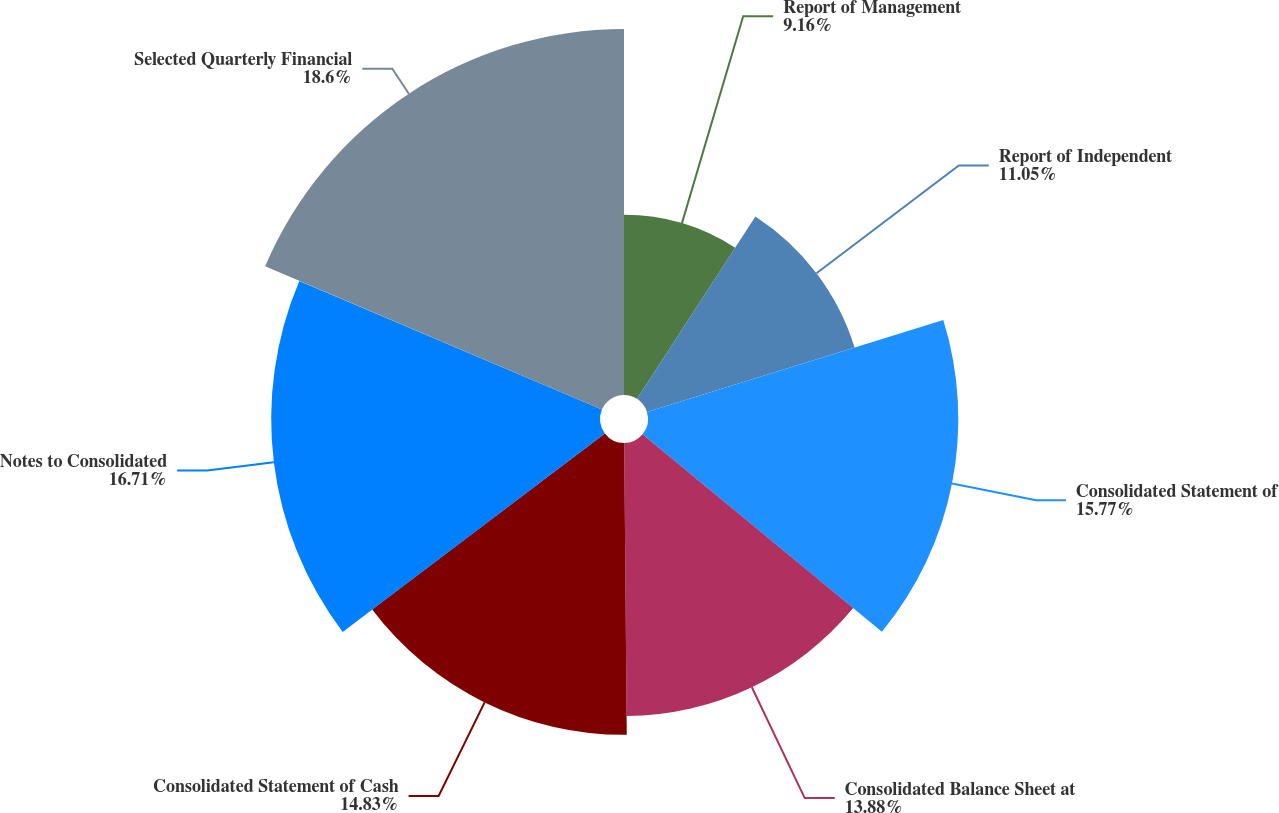<chart> <loc_0><loc_0><loc_500><loc_500><pie_chart><fcel>Report of Management<fcel>Report of Independent<fcel>Consolidated Statement of<fcel>Consolidated Balance Sheet at<fcel>Consolidated Statement of Cash<fcel>Notes to Consolidated<fcel>Selected Quarterly Financial<nl><fcel>9.16%<fcel>11.05%<fcel>15.77%<fcel>13.88%<fcel>14.83%<fcel>16.71%<fcel>18.6%<nl></chart> 